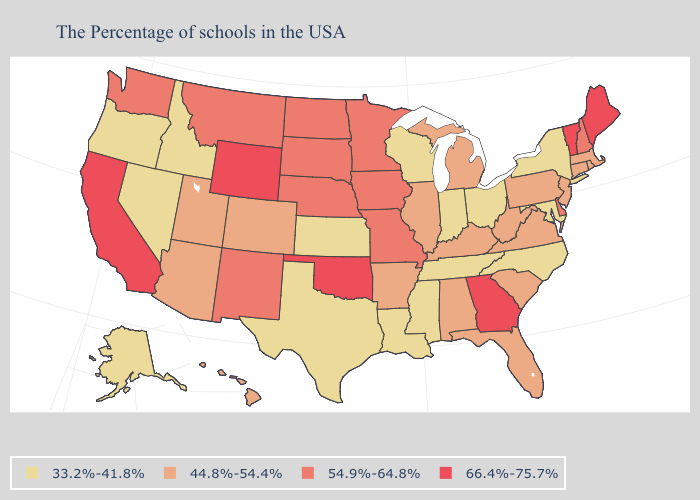Does the first symbol in the legend represent the smallest category?
Short answer required. Yes. What is the value of Michigan?
Be succinct. 44.8%-54.4%. Name the states that have a value in the range 54.9%-64.8%?
Write a very short answer. New Hampshire, Delaware, Missouri, Minnesota, Iowa, Nebraska, South Dakota, North Dakota, New Mexico, Montana, Washington. Is the legend a continuous bar?
Be succinct. No. Which states hav the highest value in the West?
Be succinct. Wyoming, California. Name the states that have a value in the range 44.8%-54.4%?
Answer briefly. Massachusetts, Rhode Island, Connecticut, New Jersey, Pennsylvania, Virginia, South Carolina, West Virginia, Florida, Michigan, Kentucky, Alabama, Illinois, Arkansas, Colorado, Utah, Arizona, Hawaii. What is the value of North Dakota?
Give a very brief answer. 54.9%-64.8%. What is the lowest value in the USA?
Give a very brief answer. 33.2%-41.8%. How many symbols are there in the legend?
Answer briefly. 4. Among the states that border South Carolina , which have the lowest value?
Concise answer only. North Carolina. What is the lowest value in states that border Massachusetts?
Concise answer only. 33.2%-41.8%. Does Louisiana have the lowest value in the USA?
Quick response, please. Yes. Does New Jersey have a lower value than Colorado?
Write a very short answer. No. Name the states that have a value in the range 33.2%-41.8%?
Give a very brief answer. New York, Maryland, North Carolina, Ohio, Indiana, Tennessee, Wisconsin, Mississippi, Louisiana, Kansas, Texas, Idaho, Nevada, Oregon, Alaska. 